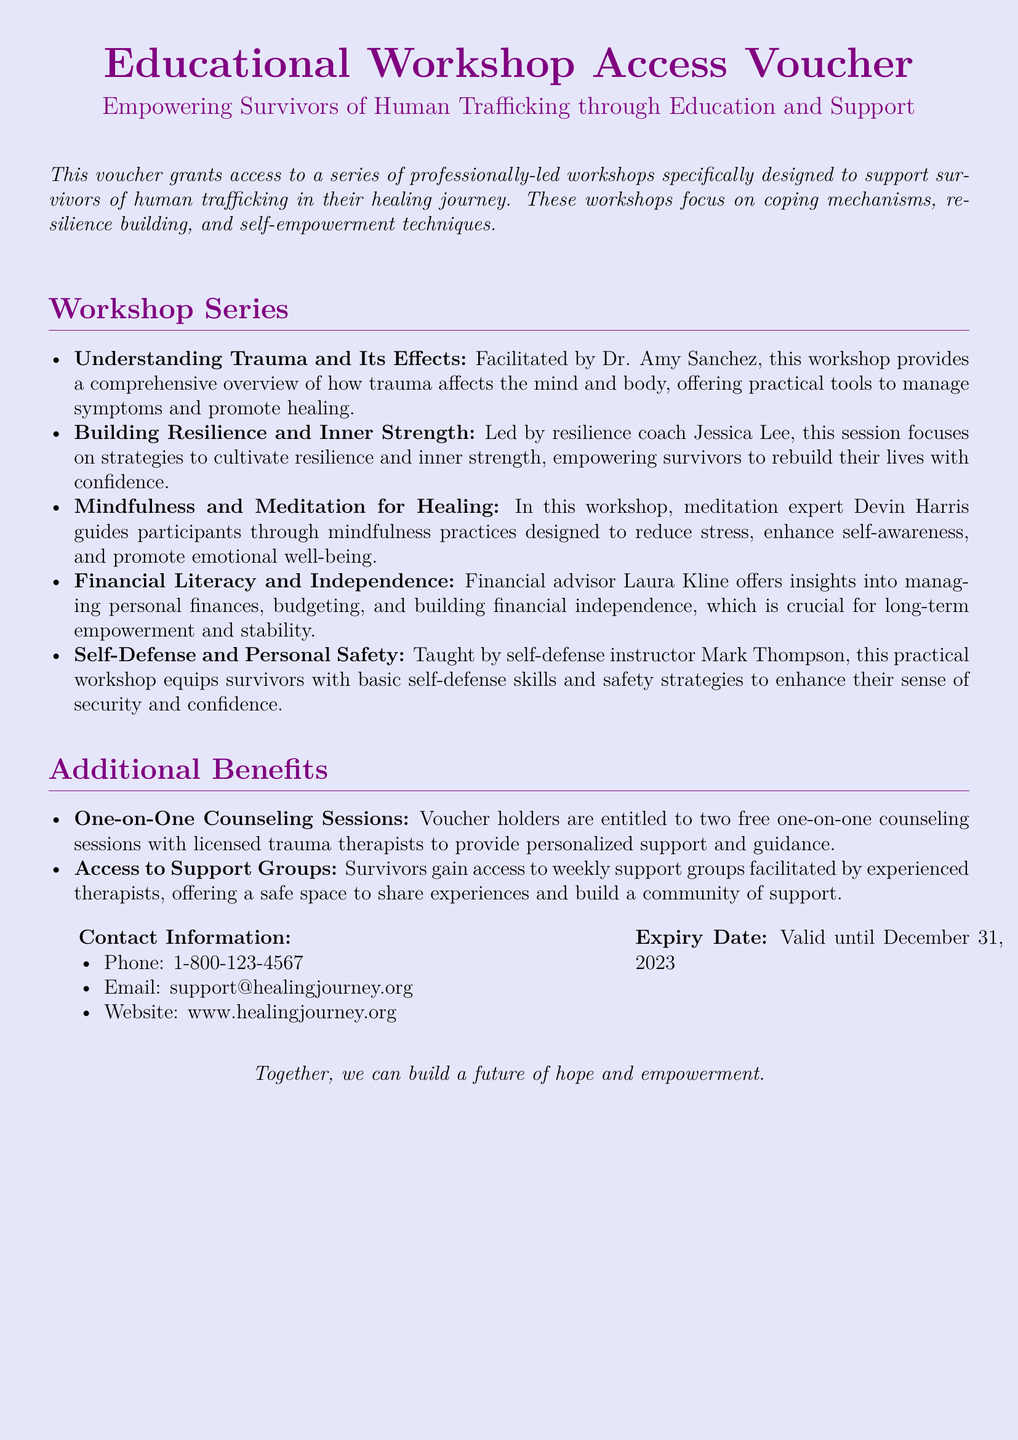what is the title of the voucher? The title is presented prominently at the top of the document.
Answer: Educational Workshop Access Voucher who facilitates the workshop on understanding trauma? This information is found in the workshop series section of the document.
Answer: Dr. Amy Sanchez how many counseling sessions are provided with the voucher? The number of counseling sessions is specified in the additional benefits section.
Answer: Two what is the expiry date of the voucher? The expiry date is clearly noted at the bottom of the document.
Answer: December 31, 2023 who leads the workshop on financial literacy? This detail can be found in the workshop series section regarding the specific presenters.
Answer: Laura Kline what is the primary focus of the workshops? The document outlines the main themes of the workshops in the introduction.
Answer: Coping mechanisms, resilience building, and self-empowerment techniques what type of safety skills are taught in the workshops? The document mentions the specific skills taught in one of the workshops.
Answer: Self-defense where can participants find support group access? The information about additional resources is listed in the additional benefits section.
Answer: Weekly support groups 